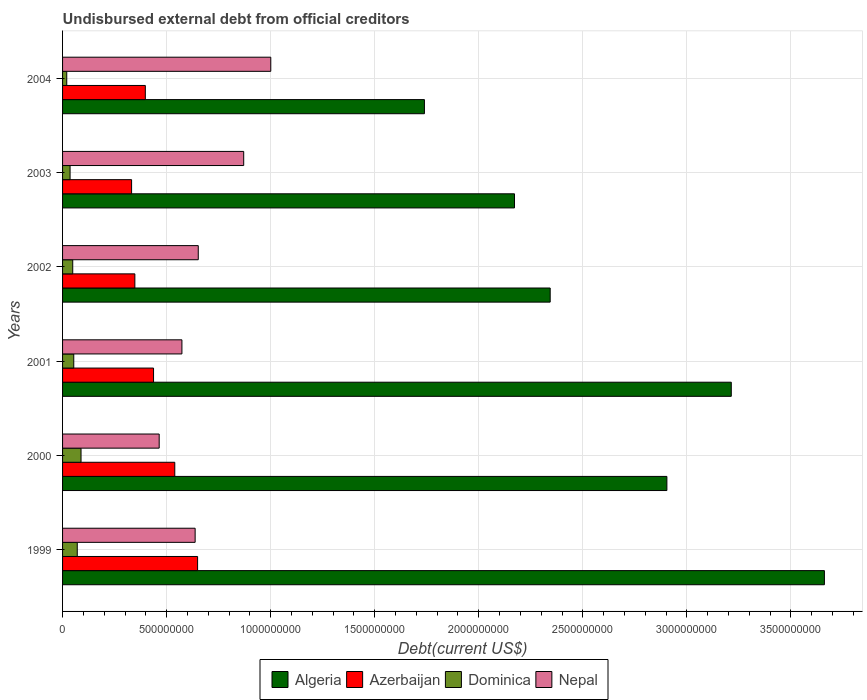Are the number of bars per tick equal to the number of legend labels?
Give a very brief answer. Yes. How many bars are there on the 5th tick from the bottom?
Make the answer very short. 4. What is the label of the 1st group of bars from the top?
Offer a very short reply. 2004. In how many cases, is the number of bars for a given year not equal to the number of legend labels?
Your answer should be compact. 0. What is the total debt in Azerbaijan in 2002?
Provide a succinct answer. 3.47e+08. Across all years, what is the maximum total debt in Azerbaijan?
Ensure brevity in your answer.  6.49e+08. Across all years, what is the minimum total debt in Azerbaijan?
Provide a short and direct response. 3.32e+08. What is the total total debt in Dominica in the graph?
Keep it short and to the point. 3.18e+08. What is the difference between the total debt in Algeria in 2000 and that in 2004?
Your answer should be very brief. 1.17e+09. What is the difference between the total debt in Dominica in 2004 and the total debt in Algeria in 2000?
Ensure brevity in your answer.  -2.88e+09. What is the average total debt in Nepal per year?
Offer a very short reply. 7.00e+08. In the year 2000, what is the difference between the total debt in Dominica and total debt in Azerbaijan?
Offer a very short reply. -4.50e+08. What is the ratio of the total debt in Dominica in 2002 to that in 2004?
Keep it short and to the point. 2.43. Is the total debt in Algeria in 2000 less than that in 2001?
Give a very brief answer. Yes. What is the difference between the highest and the second highest total debt in Algeria?
Your response must be concise. 4.47e+08. What is the difference between the highest and the lowest total debt in Algeria?
Your answer should be very brief. 1.92e+09. In how many years, is the total debt in Azerbaijan greater than the average total debt in Azerbaijan taken over all years?
Make the answer very short. 2. Is the sum of the total debt in Algeria in 2000 and 2001 greater than the maximum total debt in Dominica across all years?
Give a very brief answer. Yes. What does the 3rd bar from the top in 2002 represents?
Your response must be concise. Azerbaijan. What does the 1st bar from the bottom in 1999 represents?
Your response must be concise. Algeria. Is it the case that in every year, the sum of the total debt in Algeria and total debt in Dominica is greater than the total debt in Azerbaijan?
Offer a terse response. Yes. How many bars are there?
Provide a short and direct response. 24. How many years are there in the graph?
Make the answer very short. 6. Does the graph contain any zero values?
Give a very brief answer. No. Does the graph contain grids?
Keep it short and to the point. Yes. Where does the legend appear in the graph?
Offer a very short reply. Bottom center. How many legend labels are there?
Ensure brevity in your answer.  4. How are the legend labels stacked?
Keep it short and to the point. Horizontal. What is the title of the graph?
Provide a succinct answer. Undisbursed external debt from official creditors. What is the label or title of the X-axis?
Your answer should be compact. Debt(current US$). What is the Debt(current US$) in Algeria in 1999?
Ensure brevity in your answer.  3.66e+09. What is the Debt(current US$) of Azerbaijan in 1999?
Ensure brevity in your answer.  6.49e+08. What is the Debt(current US$) of Dominica in 1999?
Keep it short and to the point. 7.06e+07. What is the Debt(current US$) of Nepal in 1999?
Give a very brief answer. 6.37e+08. What is the Debt(current US$) in Algeria in 2000?
Provide a succinct answer. 2.90e+09. What is the Debt(current US$) in Azerbaijan in 2000?
Offer a terse response. 5.39e+08. What is the Debt(current US$) of Dominica in 2000?
Your answer should be compact. 8.88e+07. What is the Debt(current US$) in Nepal in 2000?
Provide a short and direct response. 4.64e+08. What is the Debt(current US$) in Algeria in 2001?
Offer a very short reply. 3.21e+09. What is the Debt(current US$) in Azerbaijan in 2001?
Your response must be concise. 4.37e+08. What is the Debt(current US$) of Dominica in 2001?
Your response must be concise. 5.38e+07. What is the Debt(current US$) in Nepal in 2001?
Your answer should be very brief. 5.74e+08. What is the Debt(current US$) of Algeria in 2002?
Offer a very short reply. 2.34e+09. What is the Debt(current US$) of Azerbaijan in 2002?
Provide a short and direct response. 3.47e+08. What is the Debt(current US$) of Dominica in 2002?
Offer a terse response. 4.88e+07. What is the Debt(current US$) in Nepal in 2002?
Provide a short and direct response. 6.52e+08. What is the Debt(current US$) in Algeria in 2003?
Make the answer very short. 2.17e+09. What is the Debt(current US$) of Azerbaijan in 2003?
Provide a short and direct response. 3.32e+08. What is the Debt(current US$) of Dominica in 2003?
Offer a very short reply. 3.61e+07. What is the Debt(current US$) in Nepal in 2003?
Offer a very short reply. 8.70e+08. What is the Debt(current US$) in Algeria in 2004?
Your response must be concise. 1.74e+09. What is the Debt(current US$) of Azerbaijan in 2004?
Your response must be concise. 3.98e+08. What is the Debt(current US$) in Dominica in 2004?
Offer a terse response. 2.01e+07. What is the Debt(current US$) in Nepal in 2004?
Ensure brevity in your answer.  1.00e+09. Across all years, what is the maximum Debt(current US$) of Algeria?
Offer a very short reply. 3.66e+09. Across all years, what is the maximum Debt(current US$) of Azerbaijan?
Your answer should be very brief. 6.49e+08. Across all years, what is the maximum Debt(current US$) of Dominica?
Offer a terse response. 8.88e+07. Across all years, what is the maximum Debt(current US$) in Nepal?
Provide a short and direct response. 1.00e+09. Across all years, what is the minimum Debt(current US$) of Algeria?
Your answer should be very brief. 1.74e+09. Across all years, what is the minimum Debt(current US$) in Azerbaijan?
Provide a short and direct response. 3.32e+08. Across all years, what is the minimum Debt(current US$) of Dominica?
Offer a terse response. 2.01e+07. Across all years, what is the minimum Debt(current US$) of Nepal?
Your answer should be very brief. 4.64e+08. What is the total Debt(current US$) of Algeria in the graph?
Provide a succinct answer. 1.60e+1. What is the total Debt(current US$) in Azerbaijan in the graph?
Ensure brevity in your answer.  2.70e+09. What is the total Debt(current US$) in Dominica in the graph?
Your answer should be compact. 3.18e+08. What is the total Debt(current US$) in Nepal in the graph?
Your response must be concise. 4.20e+09. What is the difference between the Debt(current US$) of Algeria in 1999 and that in 2000?
Offer a terse response. 7.57e+08. What is the difference between the Debt(current US$) in Azerbaijan in 1999 and that in 2000?
Offer a terse response. 1.10e+08. What is the difference between the Debt(current US$) of Dominica in 1999 and that in 2000?
Make the answer very short. -1.81e+07. What is the difference between the Debt(current US$) in Nepal in 1999 and that in 2000?
Your answer should be very brief. 1.73e+08. What is the difference between the Debt(current US$) of Algeria in 1999 and that in 2001?
Ensure brevity in your answer.  4.47e+08. What is the difference between the Debt(current US$) of Azerbaijan in 1999 and that in 2001?
Offer a terse response. 2.12e+08. What is the difference between the Debt(current US$) of Dominica in 1999 and that in 2001?
Your response must be concise. 1.68e+07. What is the difference between the Debt(current US$) of Nepal in 1999 and that in 2001?
Give a very brief answer. 6.35e+07. What is the difference between the Debt(current US$) in Algeria in 1999 and that in 2002?
Provide a short and direct response. 1.32e+09. What is the difference between the Debt(current US$) in Azerbaijan in 1999 and that in 2002?
Your response must be concise. 3.01e+08. What is the difference between the Debt(current US$) in Dominica in 1999 and that in 2002?
Your answer should be compact. 2.18e+07. What is the difference between the Debt(current US$) in Nepal in 1999 and that in 2002?
Your answer should be very brief. -1.50e+07. What is the difference between the Debt(current US$) of Algeria in 1999 and that in 2003?
Ensure brevity in your answer.  1.49e+09. What is the difference between the Debt(current US$) of Azerbaijan in 1999 and that in 2003?
Offer a very short reply. 3.17e+08. What is the difference between the Debt(current US$) of Dominica in 1999 and that in 2003?
Provide a succinct answer. 3.45e+07. What is the difference between the Debt(current US$) of Nepal in 1999 and that in 2003?
Keep it short and to the point. -2.33e+08. What is the difference between the Debt(current US$) in Algeria in 1999 and that in 2004?
Your response must be concise. 1.92e+09. What is the difference between the Debt(current US$) in Azerbaijan in 1999 and that in 2004?
Offer a terse response. 2.51e+08. What is the difference between the Debt(current US$) of Dominica in 1999 and that in 2004?
Your answer should be compact. 5.06e+07. What is the difference between the Debt(current US$) in Nepal in 1999 and that in 2004?
Your answer should be compact. -3.63e+08. What is the difference between the Debt(current US$) of Algeria in 2000 and that in 2001?
Offer a terse response. -3.09e+08. What is the difference between the Debt(current US$) in Azerbaijan in 2000 and that in 2001?
Your response must be concise. 1.02e+08. What is the difference between the Debt(current US$) of Dominica in 2000 and that in 2001?
Give a very brief answer. 3.49e+07. What is the difference between the Debt(current US$) of Nepal in 2000 and that in 2001?
Ensure brevity in your answer.  -1.09e+08. What is the difference between the Debt(current US$) of Algeria in 2000 and that in 2002?
Give a very brief answer. 5.61e+08. What is the difference between the Debt(current US$) of Azerbaijan in 2000 and that in 2002?
Provide a short and direct response. 1.92e+08. What is the difference between the Debt(current US$) of Dominica in 2000 and that in 2002?
Your response must be concise. 3.99e+07. What is the difference between the Debt(current US$) of Nepal in 2000 and that in 2002?
Keep it short and to the point. -1.88e+08. What is the difference between the Debt(current US$) in Algeria in 2000 and that in 2003?
Offer a terse response. 7.32e+08. What is the difference between the Debt(current US$) of Azerbaijan in 2000 and that in 2003?
Make the answer very short. 2.08e+08. What is the difference between the Debt(current US$) in Dominica in 2000 and that in 2003?
Your answer should be very brief. 5.26e+07. What is the difference between the Debt(current US$) of Nepal in 2000 and that in 2003?
Provide a short and direct response. -4.06e+08. What is the difference between the Debt(current US$) in Algeria in 2000 and that in 2004?
Offer a very short reply. 1.17e+09. What is the difference between the Debt(current US$) of Azerbaijan in 2000 and that in 2004?
Offer a terse response. 1.42e+08. What is the difference between the Debt(current US$) of Dominica in 2000 and that in 2004?
Your answer should be compact. 6.87e+07. What is the difference between the Debt(current US$) of Nepal in 2000 and that in 2004?
Give a very brief answer. -5.36e+08. What is the difference between the Debt(current US$) in Algeria in 2001 and that in 2002?
Offer a terse response. 8.70e+08. What is the difference between the Debt(current US$) in Azerbaijan in 2001 and that in 2002?
Offer a very short reply. 8.98e+07. What is the difference between the Debt(current US$) of Dominica in 2001 and that in 2002?
Provide a short and direct response. 5.00e+06. What is the difference between the Debt(current US$) in Nepal in 2001 and that in 2002?
Provide a succinct answer. -7.85e+07. What is the difference between the Debt(current US$) in Algeria in 2001 and that in 2003?
Keep it short and to the point. 1.04e+09. What is the difference between the Debt(current US$) of Azerbaijan in 2001 and that in 2003?
Offer a very short reply. 1.06e+08. What is the difference between the Debt(current US$) in Dominica in 2001 and that in 2003?
Make the answer very short. 1.77e+07. What is the difference between the Debt(current US$) in Nepal in 2001 and that in 2003?
Provide a succinct answer. -2.97e+08. What is the difference between the Debt(current US$) in Algeria in 2001 and that in 2004?
Make the answer very short. 1.47e+09. What is the difference between the Debt(current US$) in Azerbaijan in 2001 and that in 2004?
Offer a very short reply. 3.95e+07. What is the difference between the Debt(current US$) in Dominica in 2001 and that in 2004?
Provide a short and direct response. 3.38e+07. What is the difference between the Debt(current US$) in Nepal in 2001 and that in 2004?
Offer a very short reply. -4.27e+08. What is the difference between the Debt(current US$) of Algeria in 2002 and that in 2003?
Provide a succinct answer. 1.71e+08. What is the difference between the Debt(current US$) in Azerbaijan in 2002 and that in 2003?
Provide a succinct answer. 1.57e+07. What is the difference between the Debt(current US$) of Dominica in 2002 and that in 2003?
Provide a succinct answer. 1.27e+07. What is the difference between the Debt(current US$) of Nepal in 2002 and that in 2003?
Your answer should be compact. -2.18e+08. What is the difference between the Debt(current US$) of Algeria in 2002 and that in 2004?
Provide a short and direct response. 6.04e+08. What is the difference between the Debt(current US$) of Azerbaijan in 2002 and that in 2004?
Make the answer very short. -5.03e+07. What is the difference between the Debt(current US$) in Dominica in 2002 and that in 2004?
Ensure brevity in your answer.  2.88e+07. What is the difference between the Debt(current US$) of Nepal in 2002 and that in 2004?
Offer a terse response. -3.48e+08. What is the difference between the Debt(current US$) in Algeria in 2003 and that in 2004?
Provide a succinct answer. 4.33e+08. What is the difference between the Debt(current US$) in Azerbaijan in 2003 and that in 2004?
Your answer should be very brief. -6.60e+07. What is the difference between the Debt(current US$) in Dominica in 2003 and that in 2004?
Keep it short and to the point. 1.60e+07. What is the difference between the Debt(current US$) of Nepal in 2003 and that in 2004?
Make the answer very short. -1.30e+08. What is the difference between the Debt(current US$) in Algeria in 1999 and the Debt(current US$) in Azerbaijan in 2000?
Make the answer very short. 3.12e+09. What is the difference between the Debt(current US$) in Algeria in 1999 and the Debt(current US$) in Dominica in 2000?
Provide a short and direct response. 3.57e+09. What is the difference between the Debt(current US$) in Algeria in 1999 and the Debt(current US$) in Nepal in 2000?
Your answer should be very brief. 3.20e+09. What is the difference between the Debt(current US$) of Azerbaijan in 1999 and the Debt(current US$) of Dominica in 2000?
Offer a terse response. 5.60e+08. What is the difference between the Debt(current US$) in Azerbaijan in 1999 and the Debt(current US$) in Nepal in 2000?
Provide a succinct answer. 1.85e+08. What is the difference between the Debt(current US$) in Dominica in 1999 and the Debt(current US$) in Nepal in 2000?
Provide a short and direct response. -3.94e+08. What is the difference between the Debt(current US$) of Algeria in 1999 and the Debt(current US$) of Azerbaijan in 2001?
Give a very brief answer. 3.22e+09. What is the difference between the Debt(current US$) of Algeria in 1999 and the Debt(current US$) of Dominica in 2001?
Make the answer very short. 3.61e+09. What is the difference between the Debt(current US$) of Algeria in 1999 and the Debt(current US$) of Nepal in 2001?
Offer a terse response. 3.09e+09. What is the difference between the Debt(current US$) of Azerbaijan in 1999 and the Debt(current US$) of Dominica in 2001?
Ensure brevity in your answer.  5.95e+08. What is the difference between the Debt(current US$) in Azerbaijan in 1999 and the Debt(current US$) in Nepal in 2001?
Ensure brevity in your answer.  7.53e+07. What is the difference between the Debt(current US$) in Dominica in 1999 and the Debt(current US$) in Nepal in 2001?
Your response must be concise. -5.03e+08. What is the difference between the Debt(current US$) of Algeria in 1999 and the Debt(current US$) of Azerbaijan in 2002?
Your answer should be very brief. 3.31e+09. What is the difference between the Debt(current US$) of Algeria in 1999 and the Debt(current US$) of Dominica in 2002?
Offer a very short reply. 3.61e+09. What is the difference between the Debt(current US$) of Algeria in 1999 and the Debt(current US$) of Nepal in 2002?
Provide a short and direct response. 3.01e+09. What is the difference between the Debt(current US$) of Azerbaijan in 1999 and the Debt(current US$) of Dominica in 2002?
Your answer should be compact. 6.00e+08. What is the difference between the Debt(current US$) in Azerbaijan in 1999 and the Debt(current US$) in Nepal in 2002?
Offer a terse response. -3.23e+06. What is the difference between the Debt(current US$) of Dominica in 1999 and the Debt(current US$) of Nepal in 2002?
Ensure brevity in your answer.  -5.81e+08. What is the difference between the Debt(current US$) in Algeria in 1999 and the Debt(current US$) in Azerbaijan in 2003?
Your response must be concise. 3.33e+09. What is the difference between the Debt(current US$) in Algeria in 1999 and the Debt(current US$) in Dominica in 2003?
Your response must be concise. 3.62e+09. What is the difference between the Debt(current US$) of Algeria in 1999 and the Debt(current US$) of Nepal in 2003?
Offer a very short reply. 2.79e+09. What is the difference between the Debt(current US$) of Azerbaijan in 1999 and the Debt(current US$) of Dominica in 2003?
Keep it short and to the point. 6.13e+08. What is the difference between the Debt(current US$) in Azerbaijan in 1999 and the Debt(current US$) in Nepal in 2003?
Provide a short and direct response. -2.22e+08. What is the difference between the Debt(current US$) of Dominica in 1999 and the Debt(current US$) of Nepal in 2003?
Your response must be concise. -8.00e+08. What is the difference between the Debt(current US$) in Algeria in 1999 and the Debt(current US$) in Azerbaijan in 2004?
Provide a short and direct response. 3.26e+09. What is the difference between the Debt(current US$) in Algeria in 1999 and the Debt(current US$) in Dominica in 2004?
Provide a succinct answer. 3.64e+09. What is the difference between the Debt(current US$) of Algeria in 1999 and the Debt(current US$) of Nepal in 2004?
Your answer should be very brief. 2.66e+09. What is the difference between the Debt(current US$) in Azerbaijan in 1999 and the Debt(current US$) in Dominica in 2004?
Your answer should be compact. 6.29e+08. What is the difference between the Debt(current US$) in Azerbaijan in 1999 and the Debt(current US$) in Nepal in 2004?
Keep it short and to the point. -3.52e+08. What is the difference between the Debt(current US$) in Dominica in 1999 and the Debt(current US$) in Nepal in 2004?
Give a very brief answer. -9.30e+08. What is the difference between the Debt(current US$) of Algeria in 2000 and the Debt(current US$) of Azerbaijan in 2001?
Give a very brief answer. 2.47e+09. What is the difference between the Debt(current US$) of Algeria in 2000 and the Debt(current US$) of Dominica in 2001?
Provide a succinct answer. 2.85e+09. What is the difference between the Debt(current US$) of Algeria in 2000 and the Debt(current US$) of Nepal in 2001?
Provide a short and direct response. 2.33e+09. What is the difference between the Debt(current US$) of Azerbaijan in 2000 and the Debt(current US$) of Dominica in 2001?
Your response must be concise. 4.85e+08. What is the difference between the Debt(current US$) of Azerbaijan in 2000 and the Debt(current US$) of Nepal in 2001?
Your response must be concise. -3.43e+07. What is the difference between the Debt(current US$) in Dominica in 2000 and the Debt(current US$) in Nepal in 2001?
Offer a very short reply. -4.85e+08. What is the difference between the Debt(current US$) of Algeria in 2000 and the Debt(current US$) of Azerbaijan in 2002?
Provide a succinct answer. 2.56e+09. What is the difference between the Debt(current US$) of Algeria in 2000 and the Debt(current US$) of Dominica in 2002?
Provide a short and direct response. 2.86e+09. What is the difference between the Debt(current US$) of Algeria in 2000 and the Debt(current US$) of Nepal in 2002?
Give a very brief answer. 2.25e+09. What is the difference between the Debt(current US$) of Azerbaijan in 2000 and the Debt(current US$) of Dominica in 2002?
Give a very brief answer. 4.90e+08. What is the difference between the Debt(current US$) of Azerbaijan in 2000 and the Debt(current US$) of Nepal in 2002?
Offer a very short reply. -1.13e+08. What is the difference between the Debt(current US$) in Dominica in 2000 and the Debt(current US$) in Nepal in 2002?
Provide a succinct answer. -5.63e+08. What is the difference between the Debt(current US$) in Algeria in 2000 and the Debt(current US$) in Azerbaijan in 2003?
Give a very brief answer. 2.57e+09. What is the difference between the Debt(current US$) in Algeria in 2000 and the Debt(current US$) in Dominica in 2003?
Your response must be concise. 2.87e+09. What is the difference between the Debt(current US$) in Algeria in 2000 and the Debt(current US$) in Nepal in 2003?
Ensure brevity in your answer.  2.03e+09. What is the difference between the Debt(current US$) in Azerbaijan in 2000 and the Debt(current US$) in Dominica in 2003?
Your answer should be very brief. 5.03e+08. What is the difference between the Debt(current US$) of Azerbaijan in 2000 and the Debt(current US$) of Nepal in 2003?
Give a very brief answer. -3.31e+08. What is the difference between the Debt(current US$) in Dominica in 2000 and the Debt(current US$) in Nepal in 2003?
Your answer should be compact. -7.82e+08. What is the difference between the Debt(current US$) in Algeria in 2000 and the Debt(current US$) in Azerbaijan in 2004?
Provide a succinct answer. 2.51e+09. What is the difference between the Debt(current US$) of Algeria in 2000 and the Debt(current US$) of Dominica in 2004?
Offer a very short reply. 2.88e+09. What is the difference between the Debt(current US$) of Algeria in 2000 and the Debt(current US$) of Nepal in 2004?
Offer a very short reply. 1.90e+09. What is the difference between the Debt(current US$) of Azerbaijan in 2000 and the Debt(current US$) of Dominica in 2004?
Your answer should be very brief. 5.19e+08. What is the difference between the Debt(current US$) of Azerbaijan in 2000 and the Debt(current US$) of Nepal in 2004?
Offer a very short reply. -4.61e+08. What is the difference between the Debt(current US$) in Dominica in 2000 and the Debt(current US$) in Nepal in 2004?
Ensure brevity in your answer.  -9.12e+08. What is the difference between the Debt(current US$) of Algeria in 2001 and the Debt(current US$) of Azerbaijan in 2002?
Your answer should be very brief. 2.87e+09. What is the difference between the Debt(current US$) in Algeria in 2001 and the Debt(current US$) in Dominica in 2002?
Keep it short and to the point. 3.16e+09. What is the difference between the Debt(current US$) in Algeria in 2001 and the Debt(current US$) in Nepal in 2002?
Make the answer very short. 2.56e+09. What is the difference between the Debt(current US$) of Azerbaijan in 2001 and the Debt(current US$) of Dominica in 2002?
Your answer should be very brief. 3.88e+08. What is the difference between the Debt(current US$) of Azerbaijan in 2001 and the Debt(current US$) of Nepal in 2002?
Keep it short and to the point. -2.15e+08. What is the difference between the Debt(current US$) in Dominica in 2001 and the Debt(current US$) in Nepal in 2002?
Offer a terse response. -5.98e+08. What is the difference between the Debt(current US$) of Algeria in 2001 and the Debt(current US$) of Azerbaijan in 2003?
Provide a short and direct response. 2.88e+09. What is the difference between the Debt(current US$) of Algeria in 2001 and the Debt(current US$) of Dominica in 2003?
Give a very brief answer. 3.18e+09. What is the difference between the Debt(current US$) of Algeria in 2001 and the Debt(current US$) of Nepal in 2003?
Offer a terse response. 2.34e+09. What is the difference between the Debt(current US$) in Azerbaijan in 2001 and the Debt(current US$) in Dominica in 2003?
Offer a terse response. 4.01e+08. What is the difference between the Debt(current US$) in Azerbaijan in 2001 and the Debt(current US$) in Nepal in 2003?
Offer a very short reply. -4.33e+08. What is the difference between the Debt(current US$) of Dominica in 2001 and the Debt(current US$) of Nepal in 2003?
Make the answer very short. -8.17e+08. What is the difference between the Debt(current US$) of Algeria in 2001 and the Debt(current US$) of Azerbaijan in 2004?
Keep it short and to the point. 2.82e+09. What is the difference between the Debt(current US$) of Algeria in 2001 and the Debt(current US$) of Dominica in 2004?
Give a very brief answer. 3.19e+09. What is the difference between the Debt(current US$) of Algeria in 2001 and the Debt(current US$) of Nepal in 2004?
Offer a very short reply. 2.21e+09. What is the difference between the Debt(current US$) of Azerbaijan in 2001 and the Debt(current US$) of Dominica in 2004?
Offer a terse response. 4.17e+08. What is the difference between the Debt(current US$) in Azerbaijan in 2001 and the Debt(current US$) in Nepal in 2004?
Keep it short and to the point. -5.63e+08. What is the difference between the Debt(current US$) in Dominica in 2001 and the Debt(current US$) in Nepal in 2004?
Provide a succinct answer. -9.47e+08. What is the difference between the Debt(current US$) in Algeria in 2002 and the Debt(current US$) in Azerbaijan in 2003?
Provide a succinct answer. 2.01e+09. What is the difference between the Debt(current US$) of Algeria in 2002 and the Debt(current US$) of Dominica in 2003?
Keep it short and to the point. 2.31e+09. What is the difference between the Debt(current US$) in Algeria in 2002 and the Debt(current US$) in Nepal in 2003?
Ensure brevity in your answer.  1.47e+09. What is the difference between the Debt(current US$) in Azerbaijan in 2002 and the Debt(current US$) in Dominica in 2003?
Make the answer very short. 3.11e+08. What is the difference between the Debt(current US$) of Azerbaijan in 2002 and the Debt(current US$) of Nepal in 2003?
Give a very brief answer. -5.23e+08. What is the difference between the Debt(current US$) of Dominica in 2002 and the Debt(current US$) of Nepal in 2003?
Offer a terse response. -8.22e+08. What is the difference between the Debt(current US$) in Algeria in 2002 and the Debt(current US$) in Azerbaijan in 2004?
Offer a terse response. 1.95e+09. What is the difference between the Debt(current US$) in Algeria in 2002 and the Debt(current US$) in Dominica in 2004?
Keep it short and to the point. 2.32e+09. What is the difference between the Debt(current US$) of Algeria in 2002 and the Debt(current US$) of Nepal in 2004?
Make the answer very short. 1.34e+09. What is the difference between the Debt(current US$) in Azerbaijan in 2002 and the Debt(current US$) in Dominica in 2004?
Provide a short and direct response. 3.27e+08. What is the difference between the Debt(current US$) of Azerbaijan in 2002 and the Debt(current US$) of Nepal in 2004?
Keep it short and to the point. -6.53e+08. What is the difference between the Debt(current US$) in Dominica in 2002 and the Debt(current US$) in Nepal in 2004?
Provide a short and direct response. -9.52e+08. What is the difference between the Debt(current US$) in Algeria in 2003 and the Debt(current US$) in Azerbaijan in 2004?
Keep it short and to the point. 1.77e+09. What is the difference between the Debt(current US$) in Algeria in 2003 and the Debt(current US$) in Dominica in 2004?
Give a very brief answer. 2.15e+09. What is the difference between the Debt(current US$) in Algeria in 2003 and the Debt(current US$) in Nepal in 2004?
Keep it short and to the point. 1.17e+09. What is the difference between the Debt(current US$) of Azerbaijan in 2003 and the Debt(current US$) of Dominica in 2004?
Your response must be concise. 3.12e+08. What is the difference between the Debt(current US$) of Azerbaijan in 2003 and the Debt(current US$) of Nepal in 2004?
Make the answer very short. -6.69e+08. What is the difference between the Debt(current US$) in Dominica in 2003 and the Debt(current US$) in Nepal in 2004?
Your answer should be compact. -9.64e+08. What is the average Debt(current US$) in Algeria per year?
Your answer should be very brief. 2.67e+09. What is the average Debt(current US$) in Azerbaijan per year?
Keep it short and to the point. 4.50e+08. What is the average Debt(current US$) of Dominica per year?
Your answer should be compact. 5.30e+07. What is the average Debt(current US$) in Nepal per year?
Your answer should be compact. 7.00e+08. In the year 1999, what is the difference between the Debt(current US$) in Algeria and Debt(current US$) in Azerbaijan?
Provide a succinct answer. 3.01e+09. In the year 1999, what is the difference between the Debt(current US$) in Algeria and Debt(current US$) in Dominica?
Ensure brevity in your answer.  3.59e+09. In the year 1999, what is the difference between the Debt(current US$) in Algeria and Debt(current US$) in Nepal?
Offer a terse response. 3.02e+09. In the year 1999, what is the difference between the Debt(current US$) of Azerbaijan and Debt(current US$) of Dominica?
Your answer should be compact. 5.78e+08. In the year 1999, what is the difference between the Debt(current US$) in Azerbaijan and Debt(current US$) in Nepal?
Offer a very short reply. 1.18e+07. In the year 1999, what is the difference between the Debt(current US$) of Dominica and Debt(current US$) of Nepal?
Make the answer very short. -5.66e+08. In the year 2000, what is the difference between the Debt(current US$) in Algeria and Debt(current US$) in Azerbaijan?
Provide a short and direct response. 2.36e+09. In the year 2000, what is the difference between the Debt(current US$) in Algeria and Debt(current US$) in Dominica?
Make the answer very short. 2.82e+09. In the year 2000, what is the difference between the Debt(current US$) of Algeria and Debt(current US$) of Nepal?
Ensure brevity in your answer.  2.44e+09. In the year 2000, what is the difference between the Debt(current US$) in Azerbaijan and Debt(current US$) in Dominica?
Offer a terse response. 4.50e+08. In the year 2000, what is the difference between the Debt(current US$) of Azerbaijan and Debt(current US$) of Nepal?
Provide a short and direct response. 7.49e+07. In the year 2000, what is the difference between the Debt(current US$) of Dominica and Debt(current US$) of Nepal?
Offer a terse response. -3.76e+08. In the year 2001, what is the difference between the Debt(current US$) of Algeria and Debt(current US$) of Azerbaijan?
Keep it short and to the point. 2.78e+09. In the year 2001, what is the difference between the Debt(current US$) in Algeria and Debt(current US$) in Dominica?
Give a very brief answer. 3.16e+09. In the year 2001, what is the difference between the Debt(current US$) of Algeria and Debt(current US$) of Nepal?
Offer a terse response. 2.64e+09. In the year 2001, what is the difference between the Debt(current US$) of Azerbaijan and Debt(current US$) of Dominica?
Your answer should be very brief. 3.83e+08. In the year 2001, what is the difference between the Debt(current US$) in Azerbaijan and Debt(current US$) in Nepal?
Provide a succinct answer. -1.36e+08. In the year 2001, what is the difference between the Debt(current US$) of Dominica and Debt(current US$) of Nepal?
Your response must be concise. -5.20e+08. In the year 2002, what is the difference between the Debt(current US$) of Algeria and Debt(current US$) of Azerbaijan?
Make the answer very short. 2.00e+09. In the year 2002, what is the difference between the Debt(current US$) in Algeria and Debt(current US$) in Dominica?
Provide a succinct answer. 2.29e+09. In the year 2002, what is the difference between the Debt(current US$) of Algeria and Debt(current US$) of Nepal?
Offer a very short reply. 1.69e+09. In the year 2002, what is the difference between the Debt(current US$) in Azerbaijan and Debt(current US$) in Dominica?
Your answer should be compact. 2.99e+08. In the year 2002, what is the difference between the Debt(current US$) of Azerbaijan and Debt(current US$) of Nepal?
Ensure brevity in your answer.  -3.05e+08. In the year 2002, what is the difference between the Debt(current US$) in Dominica and Debt(current US$) in Nepal?
Provide a short and direct response. -6.03e+08. In the year 2003, what is the difference between the Debt(current US$) in Algeria and Debt(current US$) in Azerbaijan?
Ensure brevity in your answer.  1.84e+09. In the year 2003, what is the difference between the Debt(current US$) of Algeria and Debt(current US$) of Dominica?
Keep it short and to the point. 2.14e+09. In the year 2003, what is the difference between the Debt(current US$) of Algeria and Debt(current US$) of Nepal?
Your response must be concise. 1.30e+09. In the year 2003, what is the difference between the Debt(current US$) in Azerbaijan and Debt(current US$) in Dominica?
Your response must be concise. 2.96e+08. In the year 2003, what is the difference between the Debt(current US$) in Azerbaijan and Debt(current US$) in Nepal?
Ensure brevity in your answer.  -5.39e+08. In the year 2003, what is the difference between the Debt(current US$) in Dominica and Debt(current US$) in Nepal?
Your response must be concise. -8.34e+08. In the year 2004, what is the difference between the Debt(current US$) in Algeria and Debt(current US$) in Azerbaijan?
Your answer should be very brief. 1.34e+09. In the year 2004, what is the difference between the Debt(current US$) in Algeria and Debt(current US$) in Dominica?
Your response must be concise. 1.72e+09. In the year 2004, what is the difference between the Debt(current US$) of Algeria and Debt(current US$) of Nepal?
Give a very brief answer. 7.38e+08. In the year 2004, what is the difference between the Debt(current US$) in Azerbaijan and Debt(current US$) in Dominica?
Your answer should be very brief. 3.78e+08. In the year 2004, what is the difference between the Debt(current US$) of Azerbaijan and Debt(current US$) of Nepal?
Make the answer very short. -6.03e+08. In the year 2004, what is the difference between the Debt(current US$) of Dominica and Debt(current US$) of Nepal?
Ensure brevity in your answer.  -9.80e+08. What is the ratio of the Debt(current US$) of Algeria in 1999 to that in 2000?
Offer a very short reply. 1.26. What is the ratio of the Debt(current US$) in Azerbaijan in 1999 to that in 2000?
Your answer should be very brief. 1.2. What is the ratio of the Debt(current US$) in Dominica in 1999 to that in 2000?
Offer a terse response. 0.8. What is the ratio of the Debt(current US$) in Nepal in 1999 to that in 2000?
Your answer should be compact. 1.37. What is the ratio of the Debt(current US$) of Algeria in 1999 to that in 2001?
Your answer should be compact. 1.14. What is the ratio of the Debt(current US$) of Azerbaijan in 1999 to that in 2001?
Give a very brief answer. 1.48. What is the ratio of the Debt(current US$) of Dominica in 1999 to that in 2001?
Ensure brevity in your answer.  1.31. What is the ratio of the Debt(current US$) in Nepal in 1999 to that in 2001?
Keep it short and to the point. 1.11. What is the ratio of the Debt(current US$) in Algeria in 1999 to that in 2002?
Give a very brief answer. 1.56. What is the ratio of the Debt(current US$) of Azerbaijan in 1999 to that in 2002?
Provide a short and direct response. 1.87. What is the ratio of the Debt(current US$) in Dominica in 1999 to that in 2002?
Your response must be concise. 1.45. What is the ratio of the Debt(current US$) in Algeria in 1999 to that in 2003?
Your response must be concise. 1.69. What is the ratio of the Debt(current US$) of Azerbaijan in 1999 to that in 2003?
Ensure brevity in your answer.  1.96. What is the ratio of the Debt(current US$) of Dominica in 1999 to that in 2003?
Your answer should be compact. 1.96. What is the ratio of the Debt(current US$) of Nepal in 1999 to that in 2003?
Make the answer very short. 0.73. What is the ratio of the Debt(current US$) of Algeria in 1999 to that in 2004?
Your response must be concise. 2.11. What is the ratio of the Debt(current US$) in Azerbaijan in 1999 to that in 2004?
Offer a very short reply. 1.63. What is the ratio of the Debt(current US$) in Dominica in 1999 to that in 2004?
Give a very brief answer. 3.52. What is the ratio of the Debt(current US$) in Nepal in 1999 to that in 2004?
Keep it short and to the point. 0.64. What is the ratio of the Debt(current US$) of Algeria in 2000 to that in 2001?
Your response must be concise. 0.9. What is the ratio of the Debt(current US$) in Azerbaijan in 2000 to that in 2001?
Make the answer very short. 1.23. What is the ratio of the Debt(current US$) in Dominica in 2000 to that in 2001?
Offer a very short reply. 1.65. What is the ratio of the Debt(current US$) of Nepal in 2000 to that in 2001?
Provide a short and direct response. 0.81. What is the ratio of the Debt(current US$) in Algeria in 2000 to that in 2002?
Offer a very short reply. 1.24. What is the ratio of the Debt(current US$) in Azerbaijan in 2000 to that in 2002?
Provide a short and direct response. 1.55. What is the ratio of the Debt(current US$) in Dominica in 2000 to that in 2002?
Your response must be concise. 1.82. What is the ratio of the Debt(current US$) of Nepal in 2000 to that in 2002?
Offer a very short reply. 0.71. What is the ratio of the Debt(current US$) in Algeria in 2000 to that in 2003?
Ensure brevity in your answer.  1.34. What is the ratio of the Debt(current US$) in Azerbaijan in 2000 to that in 2003?
Ensure brevity in your answer.  1.63. What is the ratio of the Debt(current US$) in Dominica in 2000 to that in 2003?
Your answer should be compact. 2.46. What is the ratio of the Debt(current US$) of Nepal in 2000 to that in 2003?
Give a very brief answer. 0.53. What is the ratio of the Debt(current US$) of Algeria in 2000 to that in 2004?
Your response must be concise. 1.67. What is the ratio of the Debt(current US$) in Azerbaijan in 2000 to that in 2004?
Offer a terse response. 1.36. What is the ratio of the Debt(current US$) of Dominica in 2000 to that in 2004?
Provide a succinct answer. 4.42. What is the ratio of the Debt(current US$) of Nepal in 2000 to that in 2004?
Keep it short and to the point. 0.46. What is the ratio of the Debt(current US$) of Algeria in 2001 to that in 2002?
Offer a very short reply. 1.37. What is the ratio of the Debt(current US$) in Azerbaijan in 2001 to that in 2002?
Your answer should be compact. 1.26. What is the ratio of the Debt(current US$) of Dominica in 2001 to that in 2002?
Your answer should be compact. 1.1. What is the ratio of the Debt(current US$) in Nepal in 2001 to that in 2002?
Make the answer very short. 0.88. What is the ratio of the Debt(current US$) in Algeria in 2001 to that in 2003?
Provide a succinct answer. 1.48. What is the ratio of the Debt(current US$) of Azerbaijan in 2001 to that in 2003?
Offer a very short reply. 1.32. What is the ratio of the Debt(current US$) in Dominica in 2001 to that in 2003?
Give a very brief answer. 1.49. What is the ratio of the Debt(current US$) of Nepal in 2001 to that in 2003?
Ensure brevity in your answer.  0.66. What is the ratio of the Debt(current US$) in Algeria in 2001 to that in 2004?
Provide a short and direct response. 1.85. What is the ratio of the Debt(current US$) of Azerbaijan in 2001 to that in 2004?
Offer a terse response. 1.1. What is the ratio of the Debt(current US$) of Dominica in 2001 to that in 2004?
Your response must be concise. 2.68. What is the ratio of the Debt(current US$) in Nepal in 2001 to that in 2004?
Your answer should be compact. 0.57. What is the ratio of the Debt(current US$) of Algeria in 2002 to that in 2003?
Your answer should be compact. 1.08. What is the ratio of the Debt(current US$) in Azerbaijan in 2002 to that in 2003?
Your answer should be very brief. 1.05. What is the ratio of the Debt(current US$) of Dominica in 2002 to that in 2003?
Ensure brevity in your answer.  1.35. What is the ratio of the Debt(current US$) of Nepal in 2002 to that in 2003?
Ensure brevity in your answer.  0.75. What is the ratio of the Debt(current US$) in Algeria in 2002 to that in 2004?
Keep it short and to the point. 1.35. What is the ratio of the Debt(current US$) in Azerbaijan in 2002 to that in 2004?
Ensure brevity in your answer.  0.87. What is the ratio of the Debt(current US$) of Dominica in 2002 to that in 2004?
Provide a short and direct response. 2.43. What is the ratio of the Debt(current US$) in Nepal in 2002 to that in 2004?
Provide a short and direct response. 0.65. What is the ratio of the Debt(current US$) in Algeria in 2003 to that in 2004?
Your answer should be very brief. 1.25. What is the ratio of the Debt(current US$) of Azerbaijan in 2003 to that in 2004?
Provide a succinct answer. 0.83. What is the ratio of the Debt(current US$) of Dominica in 2003 to that in 2004?
Offer a very short reply. 1.8. What is the ratio of the Debt(current US$) in Nepal in 2003 to that in 2004?
Provide a succinct answer. 0.87. What is the difference between the highest and the second highest Debt(current US$) of Algeria?
Give a very brief answer. 4.47e+08. What is the difference between the highest and the second highest Debt(current US$) of Azerbaijan?
Make the answer very short. 1.10e+08. What is the difference between the highest and the second highest Debt(current US$) of Dominica?
Your answer should be compact. 1.81e+07. What is the difference between the highest and the second highest Debt(current US$) in Nepal?
Keep it short and to the point. 1.30e+08. What is the difference between the highest and the lowest Debt(current US$) in Algeria?
Keep it short and to the point. 1.92e+09. What is the difference between the highest and the lowest Debt(current US$) in Azerbaijan?
Keep it short and to the point. 3.17e+08. What is the difference between the highest and the lowest Debt(current US$) in Dominica?
Your response must be concise. 6.87e+07. What is the difference between the highest and the lowest Debt(current US$) in Nepal?
Provide a succinct answer. 5.36e+08. 